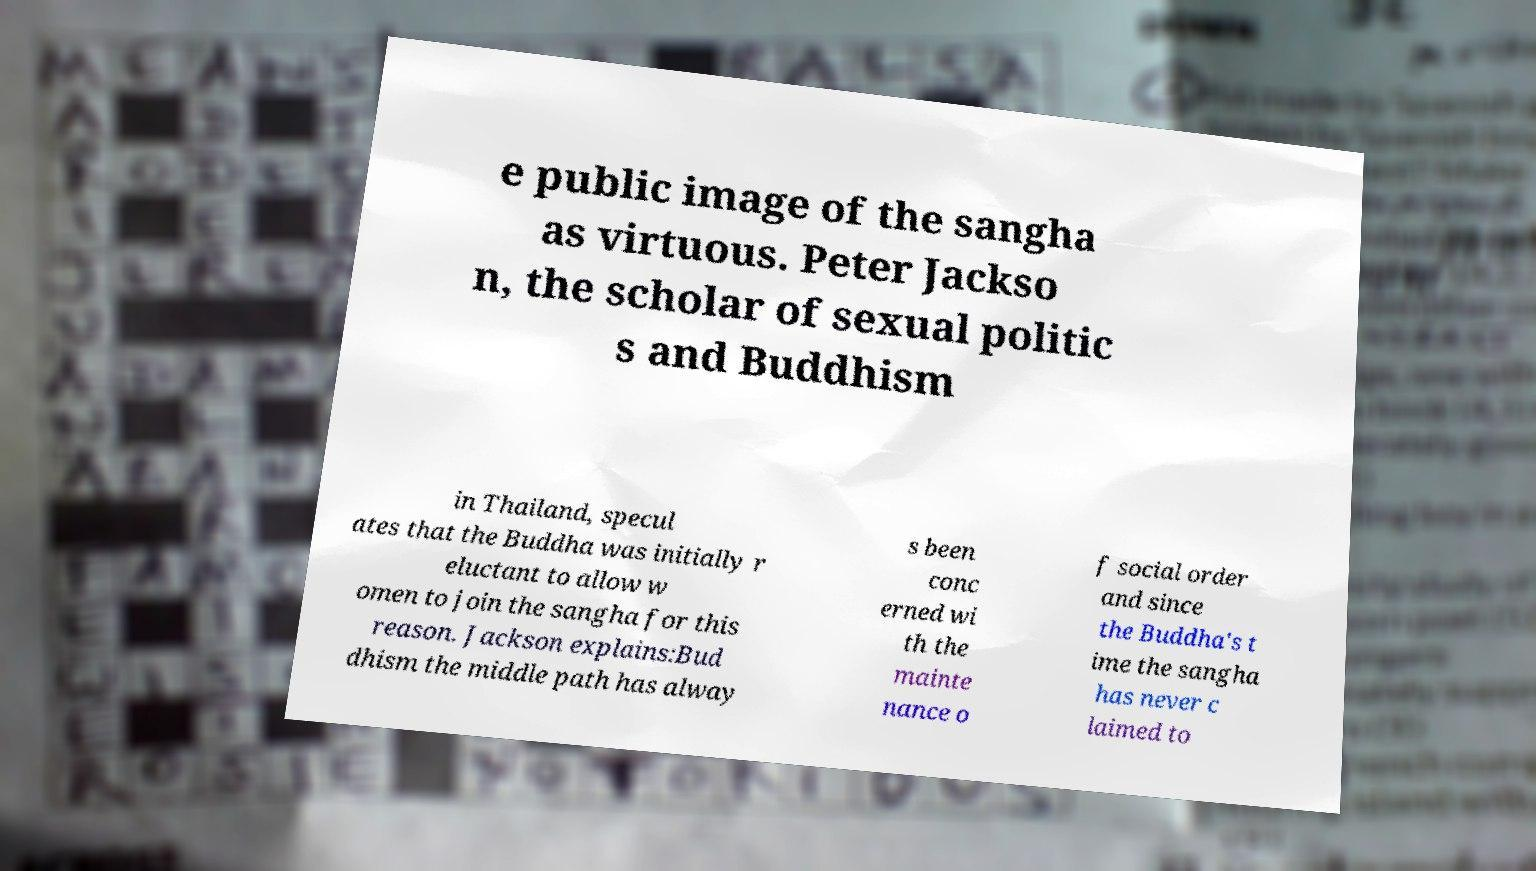I need the written content from this picture converted into text. Can you do that? e public image of the sangha as virtuous. Peter Jackso n, the scholar of sexual politic s and Buddhism in Thailand, specul ates that the Buddha was initially r eluctant to allow w omen to join the sangha for this reason. Jackson explains:Bud dhism the middle path has alway s been conc erned wi th the mainte nance o f social order and since the Buddha's t ime the sangha has never c laimed to 